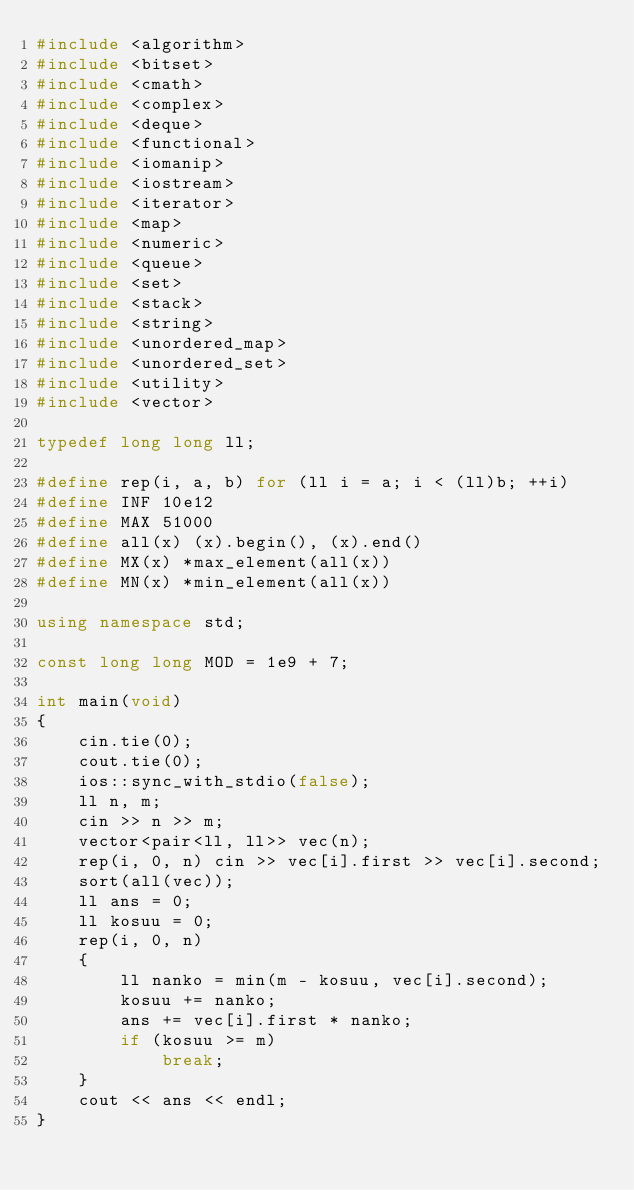Convert code to text. <code><loc_0><loc_0><loc_500><loc_500><_C++_>#include <algorithm>
#include <bitset>
#include <cmath>
#include <complex>
#include <deque>
#include <functional>
#include <iomanip>
#include <iostream>
#include <iterator>
#include <map>
#include <numeric>
#include <queue>
#include <set>
#include <stack>
#include <string>
#include <unordered_map>
#include <unordered_set>
#include <utility>
#include <vector>

typedef long long ll;

#define rep(i, a, b) for (ll i = a; i < (ll)b; ++i)
#define INF 10e12
#define MAX 51000
#define all(x) (x).begin(), (x).end()
#define MX(x) *max_element(all(x))
#define MN(x) *min_element(all(x))

using namespace std;

const long long MOD = 1e9 + 7;

int main(void)
{
    cin.tie(0);
    cout.tie(0);
    ios::sync_with_stdio(false);
    ll n, m;
    cin >> n >> m;
    vector<pair<ll, ll>> vec(n);
    rep(i, 0, n) cin >> vec[i].first >> vec[i].second;
    sort(all(vec));
    ll ans = 0;
    ll kosuu = 0;
    rep(i, 0, n)
    {
        ll nanko = min(m - kosuu, vec[i].second);
        kosuu += nanko;
        ans += vec[i].first * nanko;
        if (kosuu >= m)
            break;
    }
    cout << ans << endl;
}
</code> 